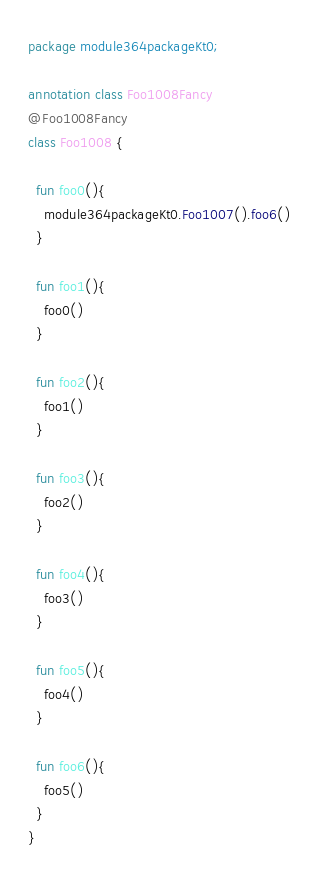Convert code to text. <code><loc_0><loc_0><loc_500><loc_500><_Kotlin_>package module364packageKt0;

annotation class Foo1008Fancy
@Foo1008Fancy
class Foo1008 {

  fun foo0(){
    module364packageKt0.Foo1007().foo6()
  }

  fun foo1(){
    foo0()
  }

  fun foo2(){
    foo1()
  }

  fun foo3(){
    foo2()
  }

  fun foo4(){
    foo3()
  }

  fun foo5(){
    foo4()
  }

  fun foo6(){
    foo5()
  }
}</code> 